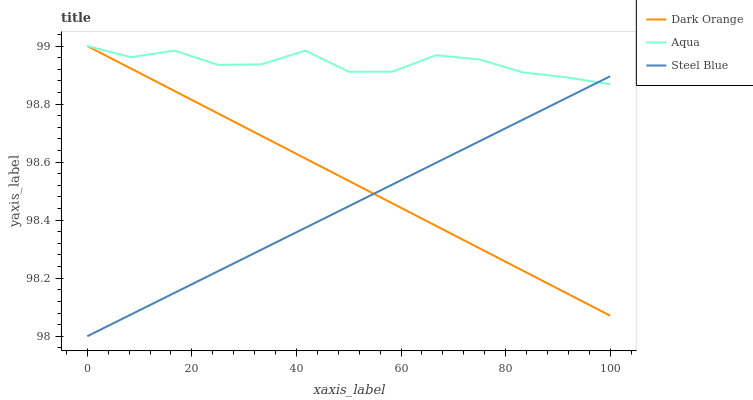Does Steel Blue have the minimum area under the curve?
Answer yes or no. Yes. Does Aqua have the maximum area under the curve?
Answer yes or no. Yes. Does Aqua have the minimum area under the curve?
Answer yes or no. No. Does Steel Blue have the maximum area under the curve?
Answer yes or no. No. Is Dark Orange the smoothest?
Answer yes or no. Yes. Is Aqua the roughest?
Answer yes or no. Yes. Is Steel Blue the smoothest?
Answer yes or no. No. Is Steel Blue the roughest?
Answer yes or no. No. Does Steel Blue have the lowest value?
Answer yes or no. Yes. Does Aqua have the lowest value?
Answer yes or no. No. Does Aqua have the highest value?
Answer yes or no. Yes. Does Steel Blue have the highest value?
Answer yes or no. No. Does Steel Blue intersect Dark Orange?
Answer yes or no. Yes. Is Steel Blue less than Dark Orange?
Answer yes or no. No. Is Steel Blue greater than Dark Orange?
Answer yes or no. No. 